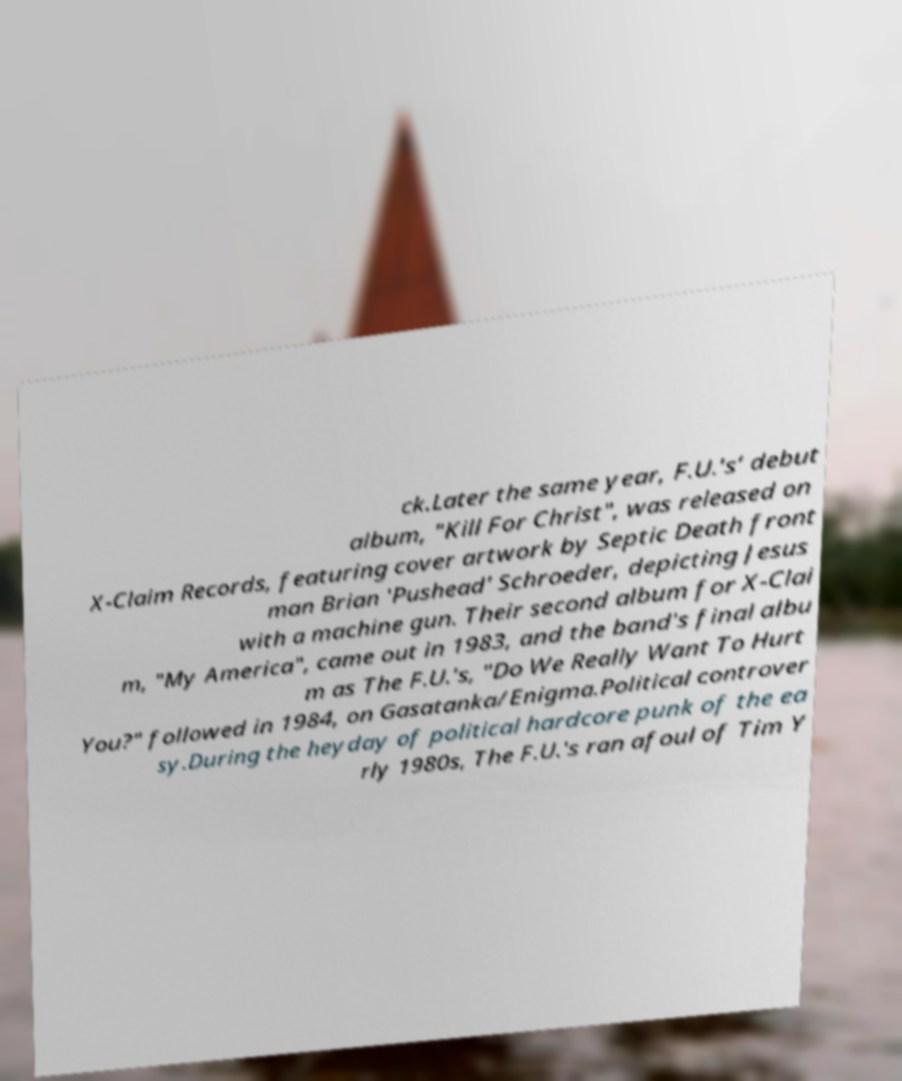Can you read and provide the text displayed in the image?This photo seems to have some interesting text. Can you extract and type it out for me? ck.Later the same year, F.U.'s‘ debut album, "Kill For Christ", was released on X-Claim Records, featuring cover artwork by Septic Death front man Brian 'Pushead' Schroeder, depicting Jesus with a machine gun. Their second album for X-Clai m, "My America", came out in 1983, and the band's final albu m as The F.U.'s, "Do We Really Want To Hurt You?" followed in 1984, on Gasatanka/Enigma.Political controver sy.During the heyday of political hardcore punk of the ea rly 1980s, The F.U.'s ran afoul of Tim Y 